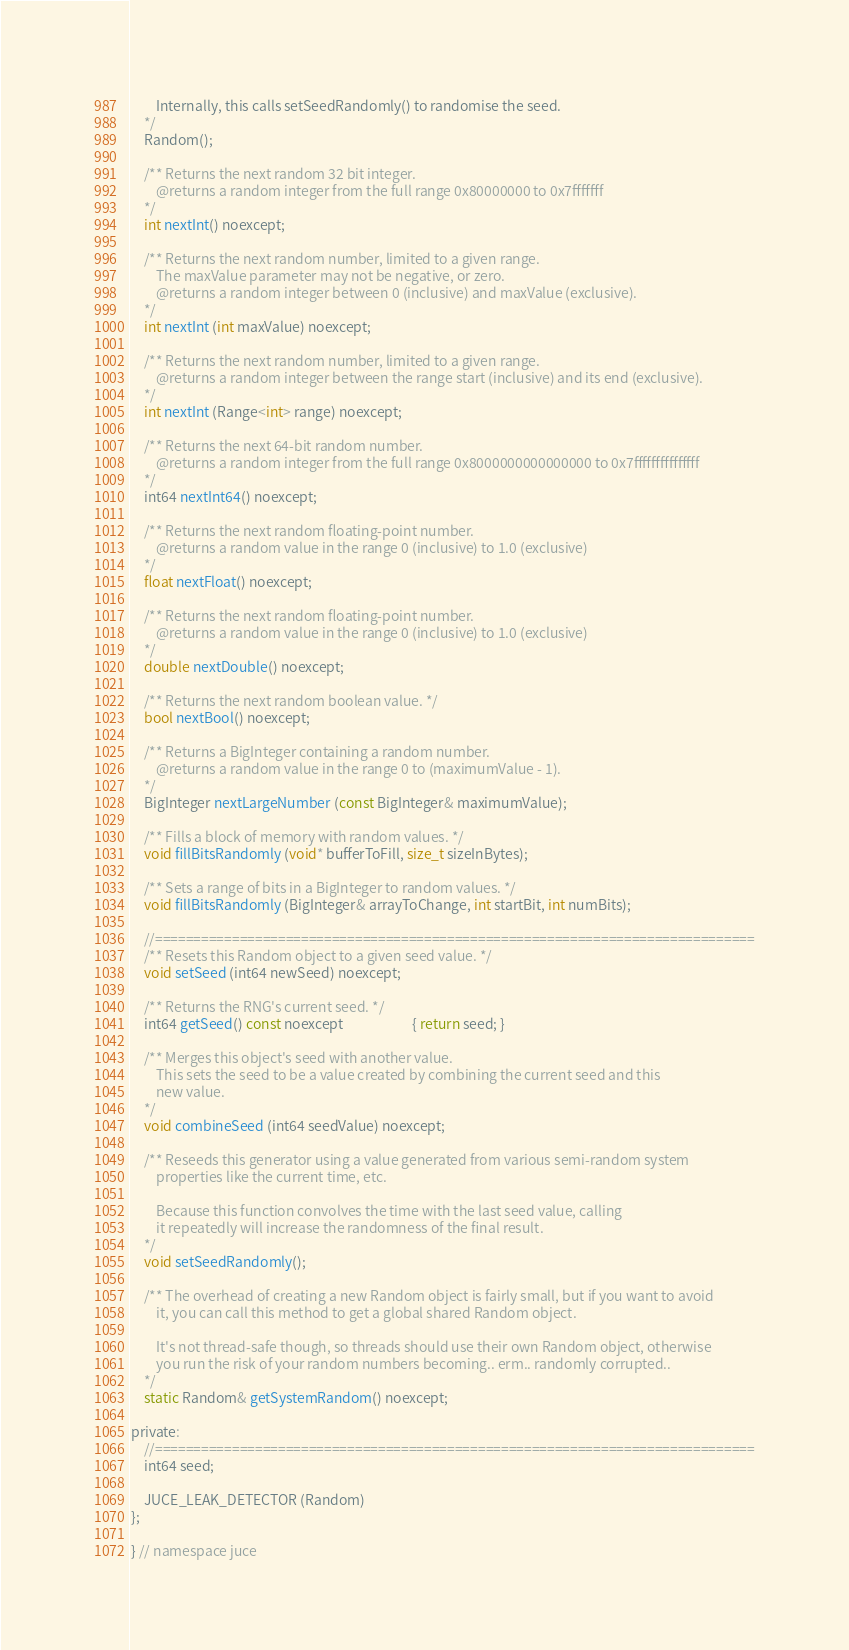Convert code to text. <code><loc_0><loc_0><loc_500><loc_500><_C_>        Internally, this calls setSeedRandomly() to randomise the seed.
    */
    Random();

    /** Returns the next random 32 bit integer.
        @returns a random integer from the full range 0x80000000 to 0x7fffffff
    */
    int nextInt() noexcept;

    /** Returns the next random number, limited to a given range.
        The maxValue parameter may not be negative, or zero.
        @returns a random integer between 0 (inclusive) and maxValue (exclusive).
    */
    int nextInt (int maxValue) noexcept;

    /** Returns the next random number, limited to a given range.
        @returns a random integer between the range start (inclusive) and its end (exclusive).
    */
    int nextInt (Range<int> range) noexcept;

    /** Returns the next 64-bit random number.
        @returns a random integer from the full range 0x8000000000000000 to 0x7fffffffffffffff
    */
    int64 nextInt64() noexcept;

    /** Returns the next random floating-point number.
        @returns a random value in the range 0 (inclusive) to 1.0 (exclusive)
    */
    float nextFloat() noexcept;

    /** Returns the next random floating-point number.
        @returns a random value in the range 0 (inclusive) to 1.0 (exclusive)
    */
    double nextDouble() noexcept;

    /** Returns the next random boolean value. */
    bool nextBool() noexcept;

    /** Returns a BigInteger containing a random number.
        @returns a random value in the range 0 to (maximumValue - 1).
    */
    BigInteger nextLargeNumber (const BigInteger& maximumValue);

    /** Fills a block of memory with random values. */
    void fillBitsRandomly (void* bufferToFill, size_t sizeInBytes);

    /** Sets a range of bits in a BigInteger to random values. */
    void fillBitsRandomly (BigInteger& arrayToChange, int startBit, int numBits);

    //==============================================================================
    /** Resets this Random object to a given seed value. */
    void setSeed (int64 newSeed) noexcept;

    /** Returns the RNG's current seed. */
    int64 getSeed() const noexcept                      { return seed; }

    /** Merges this object's seed with another value.
        This sets the seed to be a value created by combining the current seed and this
        new value.
    */
    void combineSeed (int64 seedValue) noexcept;

    /** Reseeds this generator using a value generated from various semi-random system
        properties like the current time, etc.

        Because this function convolves the time with the last seed value, calling
        it repeatedly will increase the randomness of the final result.
    */
    void setSeedRandomly();

    /** The overhead of creating a new Random object is fairly small, but if you want to avoid
        it, you can call this method to get a global shared Random object.

        It's not thread-safe though, so threads should use their own Random object, otherwise
        you run the risk of your random numbers becoming.. erm.. randomly corrupted..
    */
    static Random& getSystemRandom() noexcept;

private:
    //==============================================================================
    int64 seed;

    JUCE_LEAK_DETECTOR (Random)
};

} // namespace juce
</code> 